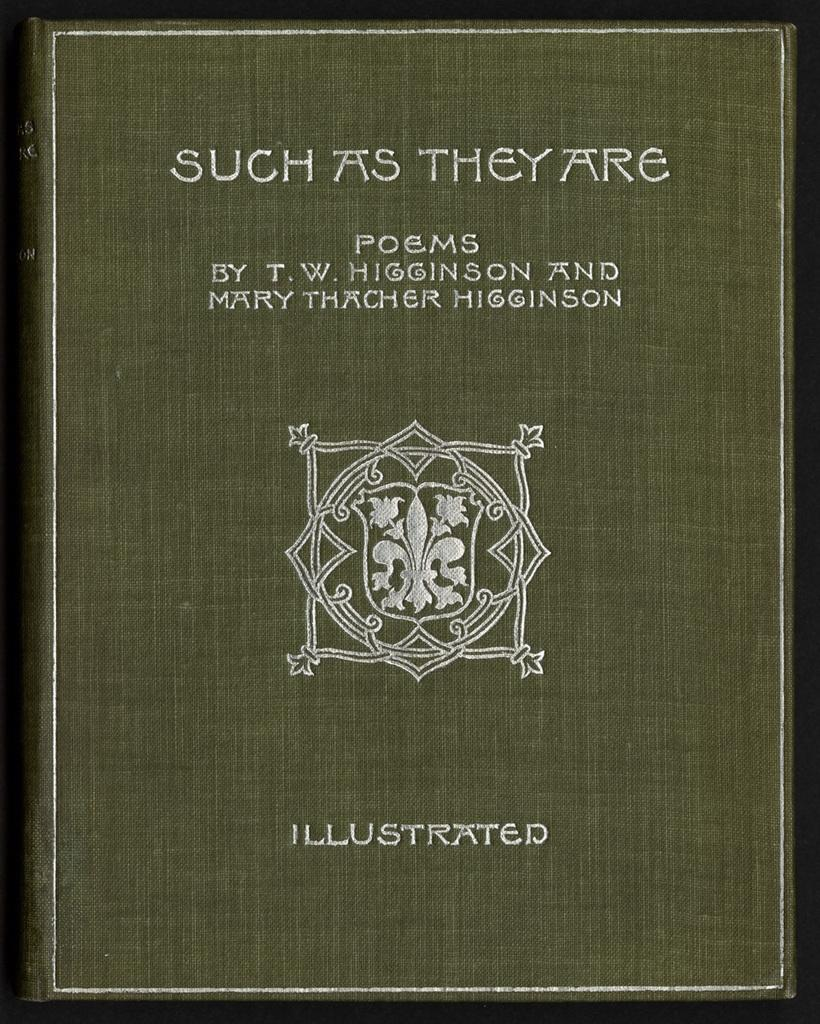<image>
Give a short and clear explanation of the subsequent image. a book that says Such as They Are on it 